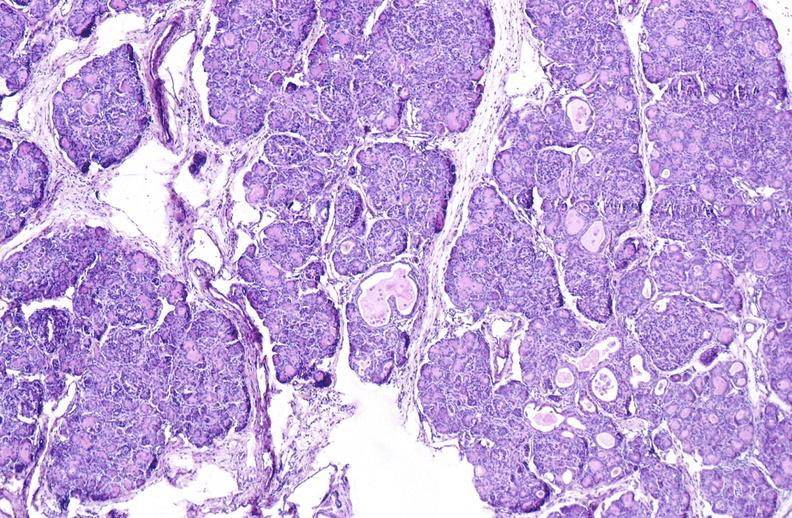s intraductal lesions present?
Answer the question using a single word or phrase. No 